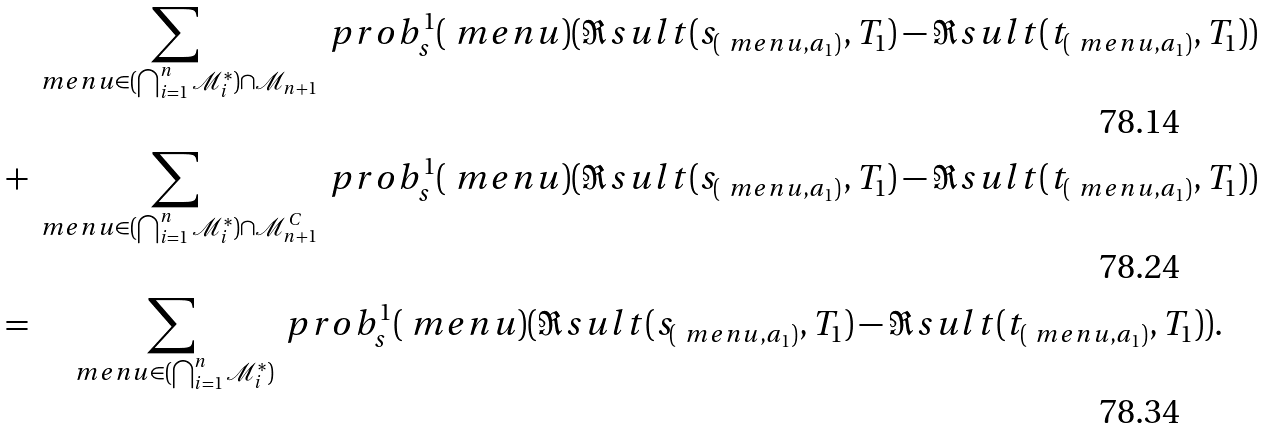Convert formula to latex. <formula><loc_0><loc_0><loc_500><loc_500>& \sum _ { \ m e n u \in ( \bigcap _ { i = 1 } ^ { n } { \mathcal { M } _ { i } ^ { * } } ) \cap \mathcal { M } _ { n + 1 } } \ p r o b _ { s } ^ { 1 } ( \ m e n u ) ( \Re s u l t ( s _ { ( \ m e n u , a _ { 1 } ) } , T _ { 1 } ) - \Re s u l t ( t _ { ( \ m e n u , a _ { 1 } ) } , T _ { 1 } ) ) \\ + & \sum _ { \ m e n u \in ( \bigcap _ { i = 1 } ^ { n } { \mathcal { M } _ { i } ^ { * } } ) \cap \mathcal { M } _ { n + 1 } ^ { C } } \ p r o b _ { s } ^ { 1 } ( \ m e n u ) ( \Re s u l t ( s _ { ( \ m e n u , a _ { 1 } ) } , T _ { 1 } ) - \Re s u l t ( t _ { ( \ m e n u , a _ { 1 } ) } , T _ { 1 } ) ) \\ = & \quad \sum _ { \ m e n u \in ( \bigcap _ { i = 1 } ^ { n } { \mathcal { M } _ { i } ^ { * } } ) } \ p r o b _ { s } ^ { 1 } ( \ m e n u ) ( \Re s u l t ( s _ { ( \ m e n u , a _ { 1 } ) } , T _ { 1 } ) - \Re s u l t ( t _ { ( \ m e n u , a _ { 1 } ) } , T _ { 1 } ) ) .</formula> 